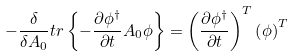Convert formula to latex. <formula><loc_0><loc_0><loc_500><loc_500>- \frac { \delta } { \delta A _ { 0 } } t r \left \{ - \frac { \partial \phi ^ { \dagger } } { \partial t } A _ { 0 } \phi \right \} = \left ( \frac { \partial \phi ^ { \dagger } } { \partial t } \right ) ^ { T } \left ( \phi \right ) ^ { T }</formula> 